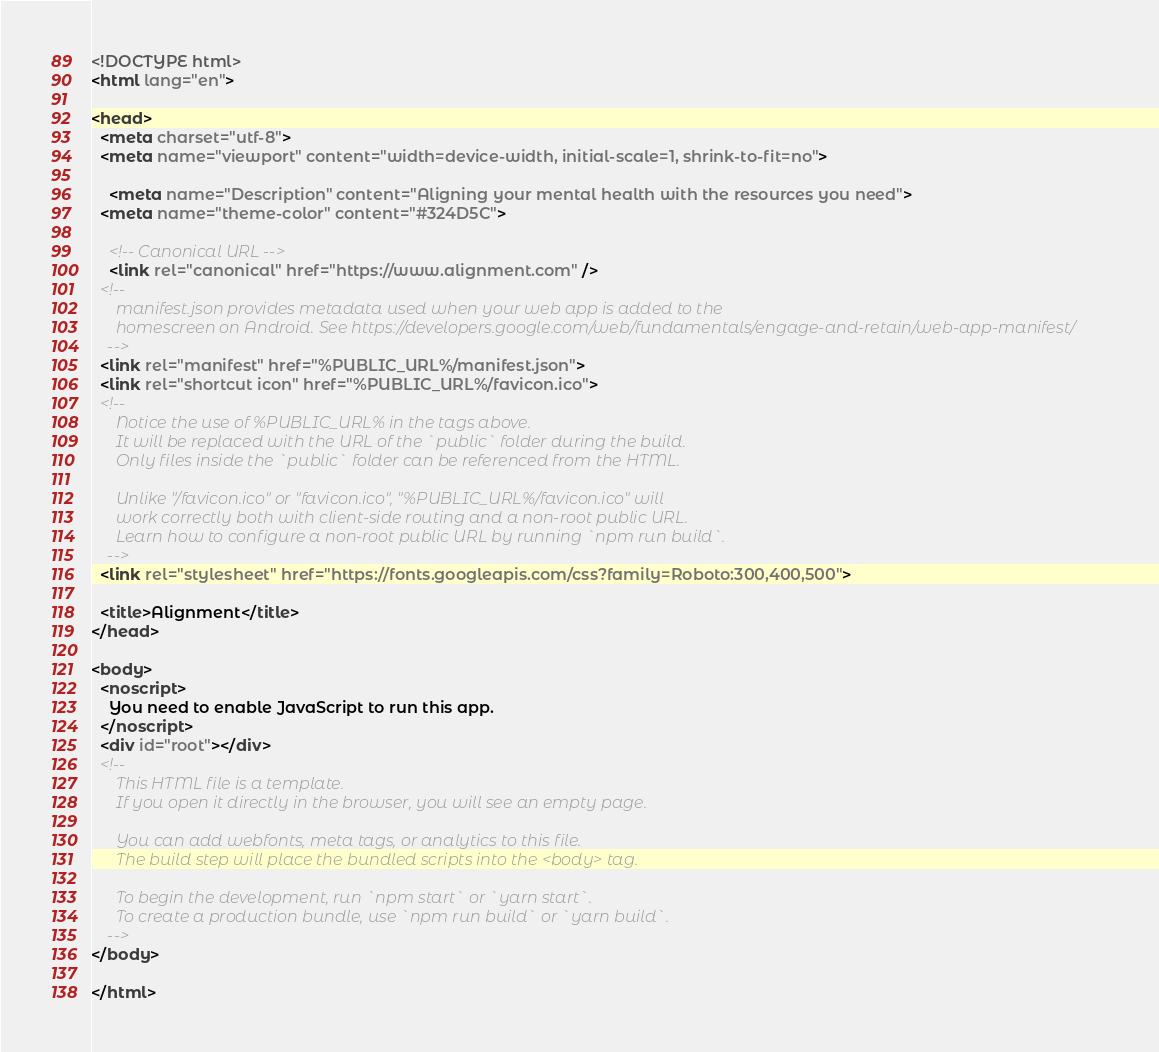<code> <loc_0><loc_0><loc_500><loc_500><_HTML_><!DOCTYPE html>
<html lang="en">

<head>
  <meta charset="utf-8">
  <meta name="viewport" content="width=device-width, initial-scale=1, shrink-to-fit=no">

	<meta name="Description" content="Aligning your mental health with the resources you need">
  <meta name="theme-color" content="#324D5C">

	<!-- Canonical URL -->
	<link rel="canonical" href="https://www.alignment.com" />
  <!--
      manifest.json provides metadata used when your web app is added to the
      homescreen on Android. See https://developers.google.com/web/fundamentals/engage-and-retain/web-app-manifest/
    -->
  <link rel="manifest" href="%PUBLIC_URL%/manifest.json">
  <link rel="shortcut icon" href="%PUBLIC_URL%/favicon.ico">
  <!--
      Notice the use of %PUBLIC_URL% in the tags above.
      It will be replaced with the URL of the `public` folder during the build.
      Only files inside the `public` folder can be referenced from the HTML.

      Unlike "/favicon.ico" or "favicon.ico", "%PUBLIC_URL%/favicon.ico" will
      work correctly both with client-side routing and a non-root public URL.
      Learn how to configure a non-root public URL by running `npm run build`.
    -->
  <link rel="stylesheet" href="https://fonts.googleapis.com/css?family=Roboto:300,400,500">

  <title>Alignment</title>
</head>

<body>
  <noscript>
    You need to enable JavaScript to run this app.
  </noscript>
  <div id="root"></div>
  <!--
      This HTML file is a template.
      If you open it directly in the browser, you will see an empty page.

      You can add webfonts, meta tags, or analytics to this file.
      The build step will place the bundled scripts into the <body> tag.

      To begin the development, run `npm start` or `yarn start`.
      To create a production bundle, use `npm run build` or `yarn build`.
    -->
</body>

</html>
</code> 